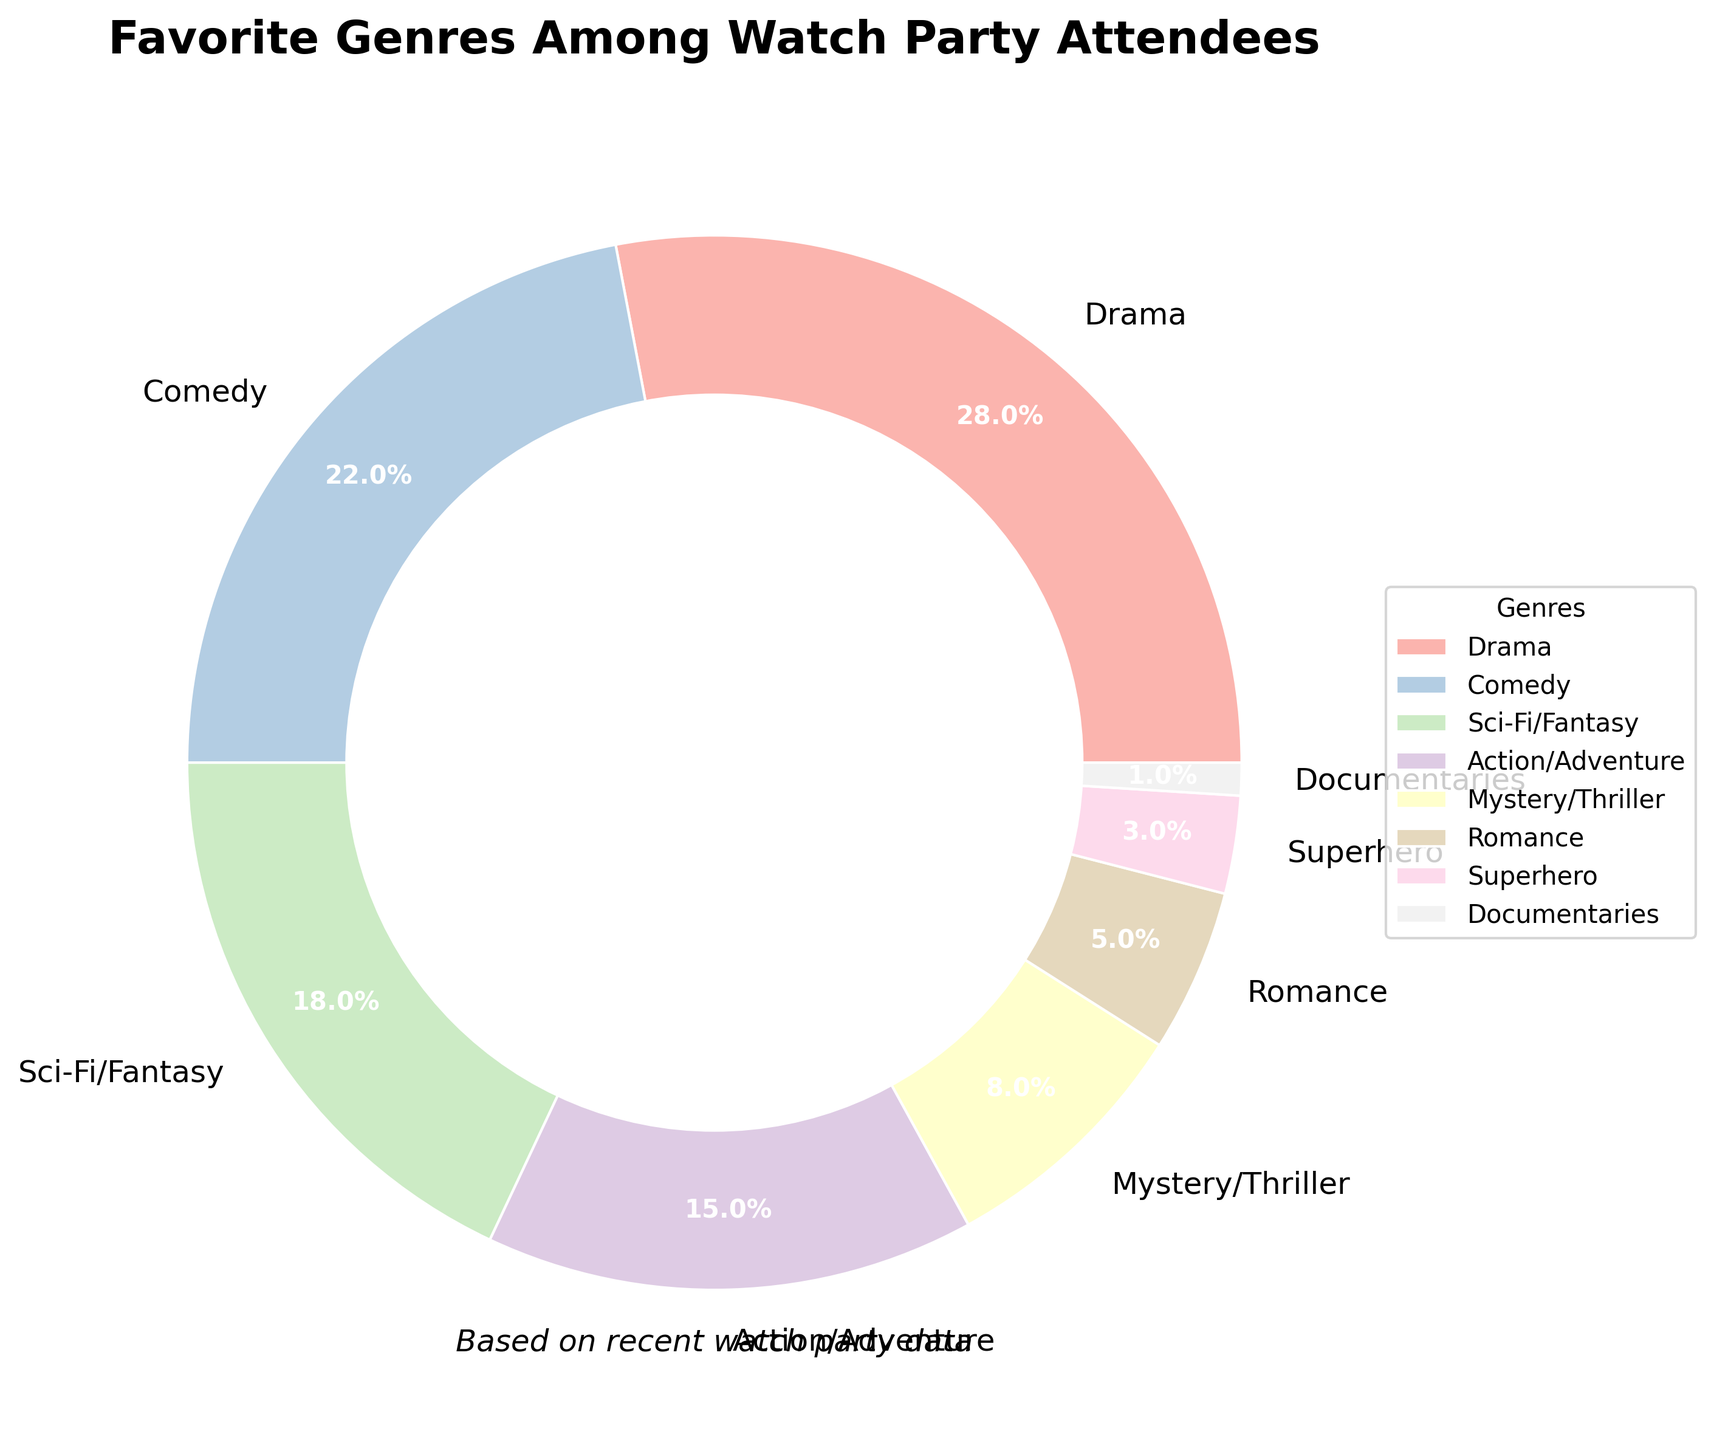What's the most popular genre among the watch party attendees? The chart shows the distribution of genres, with Drama having the largest slice at 28%. Therefore, Drama is the most popular genre.
Answer: Drama Which genres have a combined percentage that exceeds 50%? By adding the percentages of the largest slices until the total exceeds 50%:
Drama (28%) + Comedy (22%) = 50%. So, Drama and Comedy together make up exactly 50%. Since rounding might be involved, technically 50% here would suffice.
Answer: Drama, Comedy Which genre has the smallest share in the pie chart? By observing the chart, Documentaries have the smallest slice at 1%. Thus, Documentaries have the smallest share.
Answer: Documentaries What is the difference in the percentage between Action/Adventure and Romance? The percentage for Action/Adventure is 15% and for Romance is 5%, so the difference is 15% - 5% = 10%.
Answer: 10% Are there more attendees who prefer Sci-Fi/Fantasy or Mystery/Thriller? Sci-Fi/Fantasy has a slice representing 18%, while Mystery/Thriller is 8%. Thus, Sci-Fi/Fantasy is preferred by more attendees.
Answer: Sci-Fi/Fantasy What is the total percentage of attendees who prefer Superhero or Documentaries genres? The percentages for Superhero and Documentaries are 3% and 1%, respectively. The total is 3% + 1% = 4%.
Answer: 4% Which genre represents exactly half of the most popular genre? The most popular genre, Drama, has a percentage of 28%. Half of 28% is 14%. The nearest genre, Action/Adventure, is represented by 15%, but none exactly match 14%. Therefore, no genre represents exactly half of Drama.
Answer: None How much more popular is Comedy compared to Sci-Fi/Fantasy? Comedy has 22% while Sci-Fi/Fantasy has 18%. The difference is 22% - 18% = 4%.
Answer: 4% Which is the least popular genre among genres that have more than 10% preference? Among the genres with more than 10%, Action/Adventure has the least with 15%.
Answer: Action/Adventure 